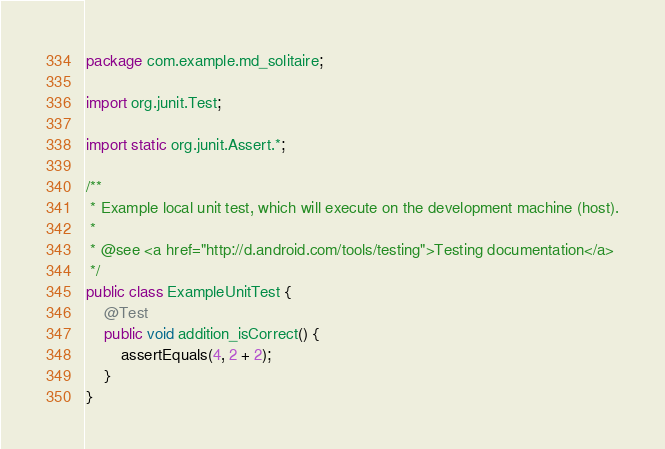<code> <loc_0><loc_0><loc_500><loc_500><_Java_>package com.example.md_solitaire;

import org.junit.Test;

import static org.junit.Assert.*;

/**
 * Example local unit test, which will execute on the development machine (host).
 *
 * @see <a href="http://d.android.com/tools/testing">Testing documentation</a>
 */
public class ExampleUnitTest {
    @Test
    public void addition_isCorrect() {
        assertEquals(4, 2 + 2);
    }
}</code> 